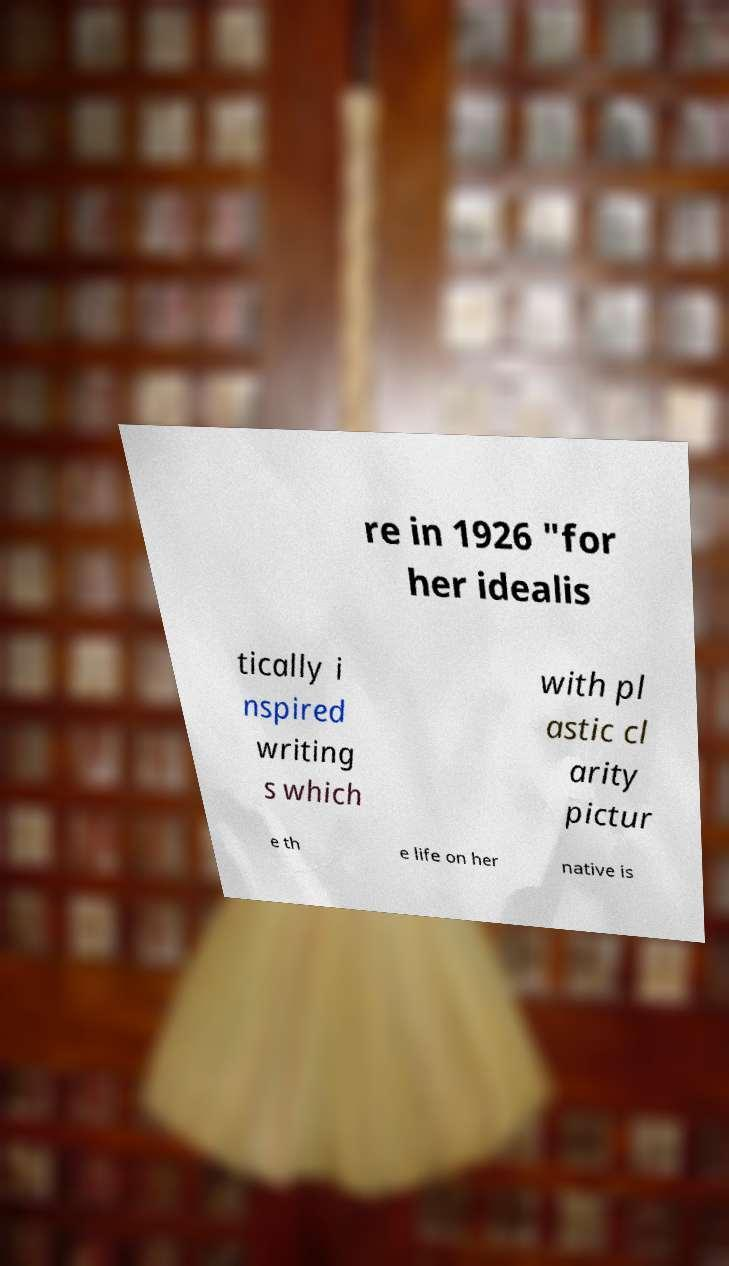Please read and relay the text visible in this image. What does it say? re in 1926 "for her idealis tically i nspired writing s which with pl astic cl arity pictur e th e life on her native is 